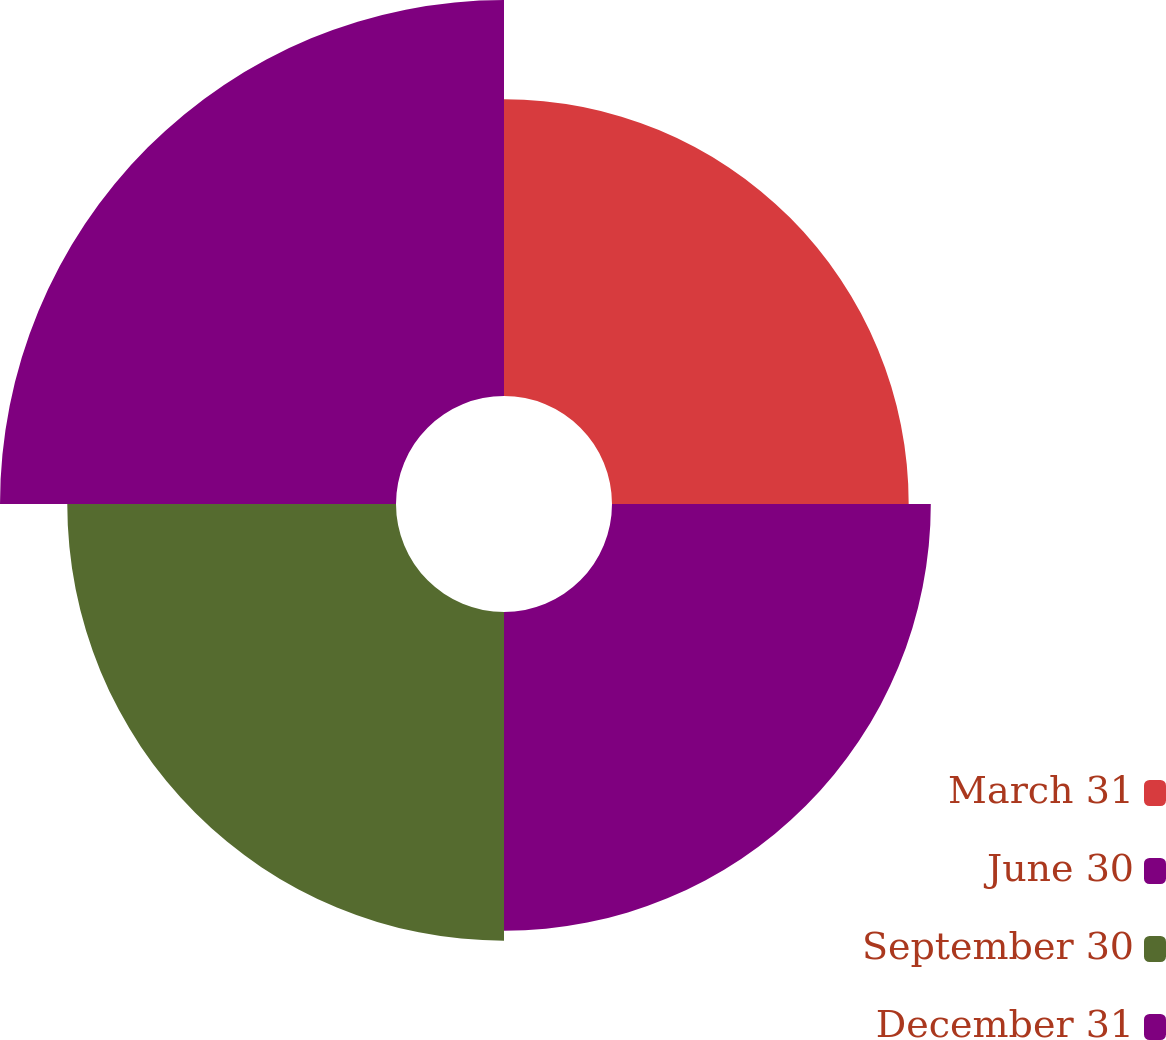<chart> <loc_0><loc_0><loc_500><loc_500><pie_chart><fcel>March 31<fcel>June 30<fcel>September 30<fcel>December 31<nl><fcel>22.14%<fcel>23.79%<fcel>24.53%<fcel>29.55%<nl></chart> 